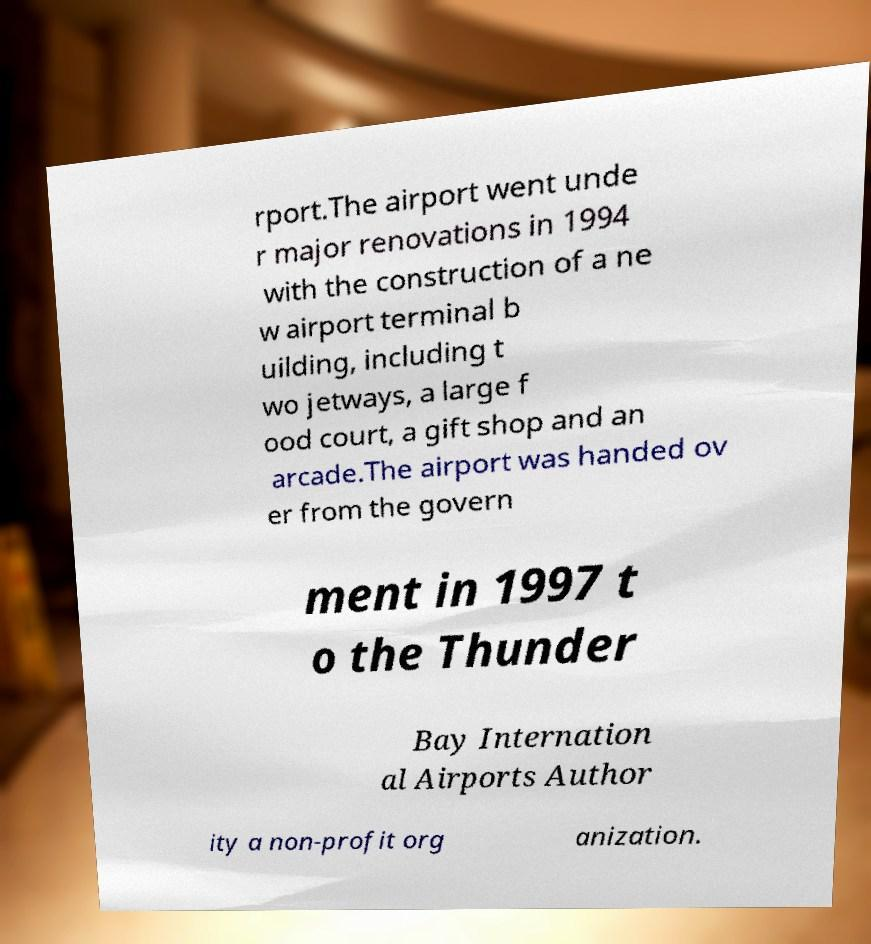Could you extract and type out the text from this image? rport.The airport went unde r major renovations in 1994 with the construction of a ne w airport terminal b uilding, including t wo jetways, a large f ood court, a gift shop and an arcade.The airport was handed ov er from the govern ment in 1997 t o the Thunder Bay Internation al Airports Author ity a non-profit org anization. 